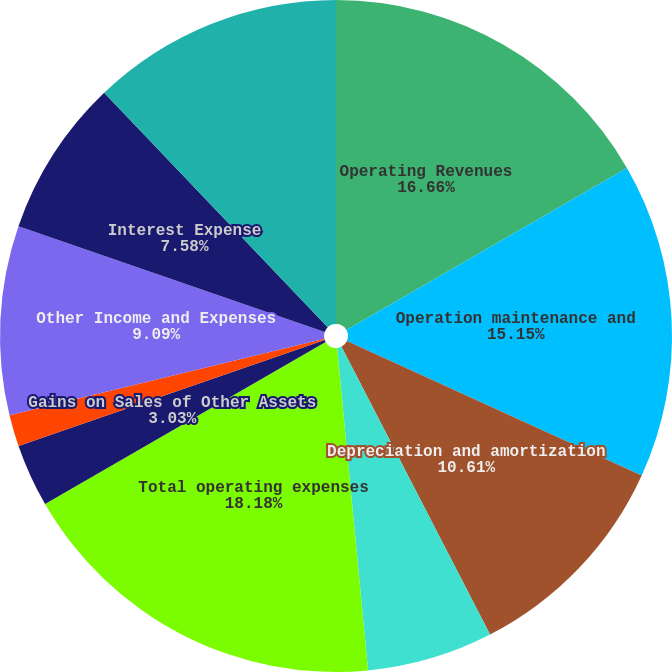<chart> <loc_0><loc_0><loc_500><loc_500><pie_chart><fcel>Operating Revenues<fcel>Operation maintenance and<fcel>Depreciation and amortization<fcel>Property and other taxes<fcel>Total operating expenses<fcel>Gains on Sales of Other Assets<fcel>Operating Loss<fcel>Other Income and Expenses<fcel>Interest Expense<fcel>Loss Before Income Taxes<nl><fcel>16.66%<fcel>15.15%<fcel>10.61%<fcel>6.06%<fcel>18.18%<fcel>3.03%<fcel>1.52%<fcel>9.09%<fcel>7.58%<fcel>12.12%<nl></chart> 